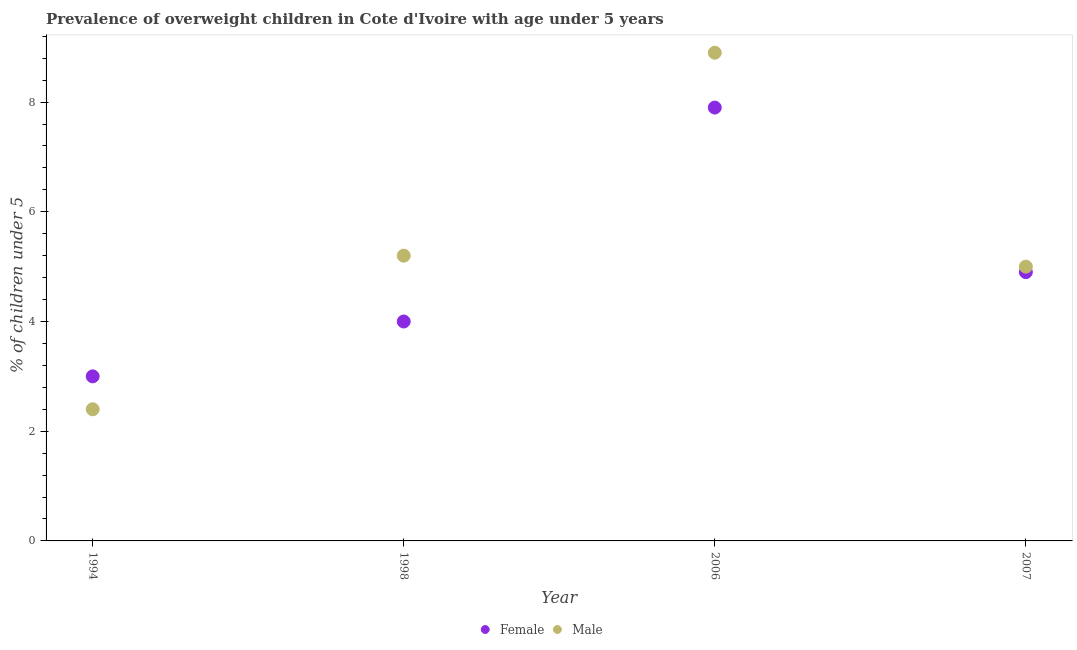How many different coloured dotlines are there?
Your answer should be very brief. 2. Is the number of dotlines equal to the number of legend labels?
Offer a very short reply. Yes. What is the percentage of obese female children in 2007?
Your answer should be very brief. 4.9. Across all years, what is the maximum percentage of obese male children?
Offer a very short reply. 8.9. Across all years, what is the minimum percentage of obese male children?
Provide a short and direct response. 2.4. In which year was the percentage of obese male children maximum?
Offer a terse response. 2006. In which year was the percentage of obese male children minimum?
Give a very brief answer. 1994. What is the total percentage of obese female children in the graph?
Your answer should be compact. 19.8. What is the difference between the percentage of obese female children in 1994 and that in 2006?
Make the answer very short. -4.9. What is the difference between the percentage of obese female children in 2007 and the percentage of obese male children in 1998?
Keep it short and to the point. -0.3. What is the average percentage of obese male children per year?
Provide a succinct answer. 5.37. In the year 1994, what is the difference between the percentage of obese male children and percentage of obese female children?
Make the answer very short. -0.6. In how many years, is the percentage of obese female children greater than 0.8 %?
Provide a succinct answer. 4. What is the ratio of the percentage of obese male children in 2006 to that in 2007?
Ensure brevity in your answer.  1.78. Is the percentage of obese female children in 2006 less than that in 2007?
Make the answer very short. No. What is the difference between the highest and the second highest percentage of obese male children?
Provide a short and direct response. 3.7. What is the difference between the highest and the lowest percentage of obese male children?
Your response must be concise. 6.5. How many dotlines are there?
Offer a terse response. 2. Are the values on the major ticks of Y-axis written in scientific E-notation?
Keep it short and to the point. No. Does the graph contain grids?
Your answer should be very brief. No. Where does the legend appear in the graph?
Provide a short and direct response. Bottom center. What is the title of the graph?
Your answer should be compact. Prevalence of overweight children in Cote d'Ivoire with age under 5 years. Does "Taxes" appear as one of the legend labels in the graph?
Give a very brief answer. No. What is the label or title of the Y-axis?
Offer a terse response.  % of children under 5. What is the  % of children under 5 of Male in 1994?
Your answer should be compact. 2.4. What is the  % of children under 5 of Female in 1998?
Offer a very short reply. 4. What is the  % of children under 5 in Male in 1998?
Provide a succinct answer. 5.2. What is the  % of children under 5 in Female in 2006?
Make the answer very short. 7.9. What is the  % of children under 5 in Male in 2006?
Give a very brief answer. 8.9. What is the  % of children under 5 of Female in 2007?
Keep it short and to the point. 4.9. What is the  % of children under 5 in Male in 2007?
Make the answer very short. 5. Across all years, what is the maximum  % of children under 5 in Female?
Provide a short and direct response. 7.9. Across all years, what is the maximum  % of children under 5 in Male?
Ensure brevity in your answer.  8.9. Across all years, what is the minimum  % of children under 5 of Female?
Make the answer very short. 3. Across all years, what is the minimum  % of children under 5 of Male?
Offer a terse response. 2.4. What is the total  % of children under 5 in Female in the graph?
Your response must be concise. 19.8. What is the total  % of children under 5 of Male in the graph?
Make the answer very short. 21.5. What is the difference between the  % of children under 5 of Female in 1994 and that in 1998?
Your response must be concise. -1. What is the difference between the  % of children under 5 in Male in 1994 and that in 1998?
Offer a terse response. -2.8. What is the difference between the  % of children under 5 in Female in 1998 and that in 2007?
Give a very brief answer. -0.9. What is the difference between the  % of children under 5 of Female in 2006 and that in 2007?
Give a very brief answer. 3. What is the difference between the  % of children under 5 in Male in 2006 and that in 2007?
Your answer should be very brief. 3.9. What is the difference between the  % of children under 5 of Female in 1998 and the  % of children under 5 of Male in 2007?
Your response must be concise. -1. What is the difference between the  % of children under 5 of Female in 2006 and the  % of children under 5 of Male in 2007?
Your answer should be very brief. 2.9. What is the average  % of children under 5 in Female per year?
Provide a succinct answer. 4.95. What is the average  % of children under 5 in Male per year?
Offer a very short reply. 5.38. In the year 1994, what is the difference between the  % of children under 5 of Female and  % of children under 5 of Male?
Your answer should be very brief. 0.6. In the year 2006, what is the difference between the  % of children under 5 in Female and  % of children under 5 in Male?
Give a very brief answer. -1. What is the ratio of the  % of children under 5 of Male in 1994 to that in 1998?
Provide a succinct answer. 0.46. What is the ratio of the  % of children under 5 of Female in 1994 to that in 2006?
Your response must be concise. 0.38. What is the ratio of the  % of children under 5 of Male in 1994 to that in 2006?
Provide a short and direct response. 0.27. What is the ratio of the  % of children under 5 of Female in 1994 to that in 2007?
Make the answer very short. 0.61. What is the ratio of the  % of children under 5 of Male in 1994 to that in 2007?
Keep it short and to the point. 0.48. What is the ratio of the  % of children under 5 of Female in 1998 to that in 2006?
Your answer should be very brief. 0.51. What is the ratio of the  % of children under 5 of Male in 1998 to that in 2006?
Ensure brevity in your answer.  0.58. What is the ratio of the  % of children under 5 of Female in 1998 to that in 2007?
Your response must be concise. 0.82. What is the ratio of the  % of children under 5 of Female in 2006 to that in 2007?
Your answer should be compact. 1.61. What is the ratio of the  % of children under 5 of Male in 2006 to that in 2007?
Give a very brief answer. 1.78. What is the difference between the highest and the second highest  % of children under 5 in Female?
Give a very brief answer. 3. What is the difference between the highest and the second highest  % of children under 5 of Male?
Give a very brief answer. 3.7. What is the difference between the highest and the lowest  % of children under 5 in Female?
Provide a succinct answer. 4.9. 